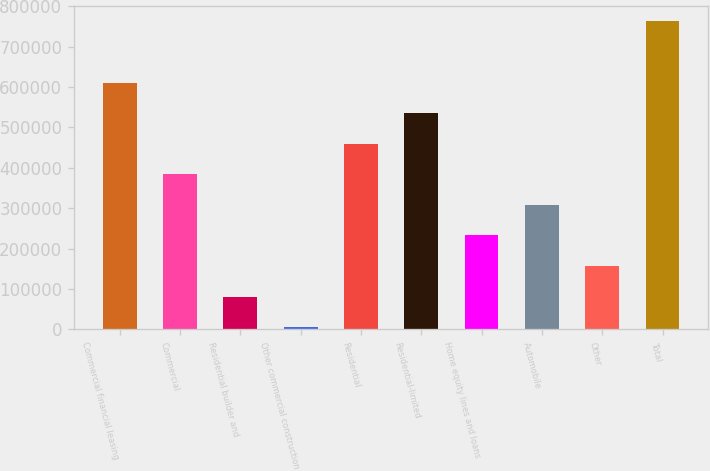Convert chart to OTSL. <chart><loc_0><loc_0><loc_500><loc_500><bar_chart><fcel>Commercial financial leasing<fcel>Commercial<fcel>Residential builder and<fcel>Other commercial construction<fcel>Residential<fcel>Residential-limited<fcel>Home equity lines and loans<fcel>Automobile<fcel>Other<fcel>Total<nl><fcel>611060<fcel>383968<fcel>81177.5<fcel>5480<fcel>459665<fcel>535362<fcel>232572<fcel>308270<fcel>156875<fcel>762455<nl></chart> 